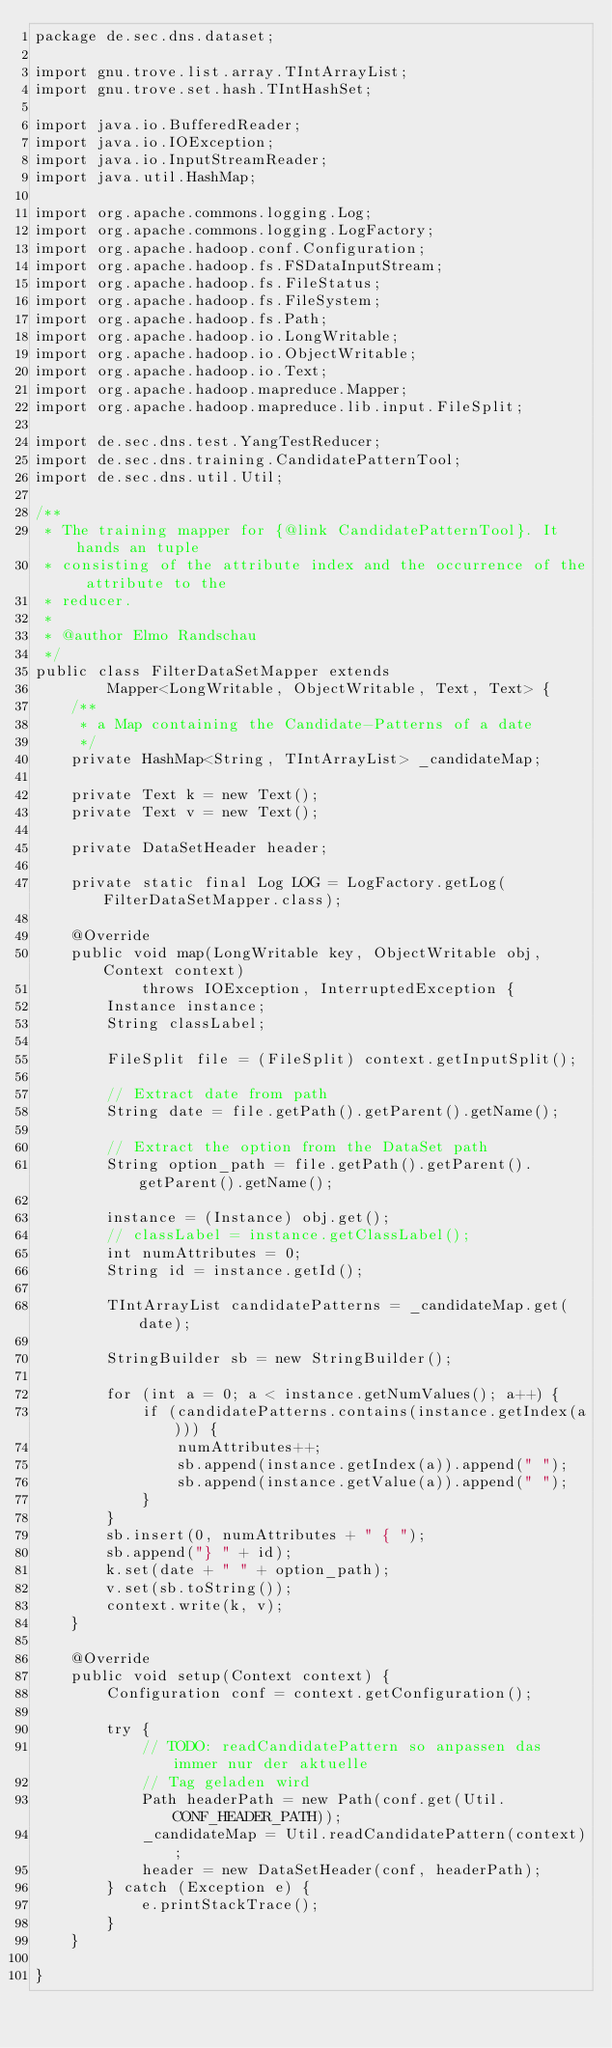<code> <loc_0><loc_0><loc_500><loc_500><_Java_>package de.sec.dns.dataset;

import gnu.trove.list.array.TIntArrayList;
import gnu.trove.set.hash.TIntHashSet;

import java.io.BufferedReader;
import java.io.IOException;
import java.io.InputStreamReader;
import java.util.HashMap;

import org.apache.commons.logging.Log;
import org.apache.commons.logging.LogFactory;
import org.apache.hadoop.conf.Configuration;
import org.apache.hadoop.fs.FSDataInputStream;
import org.apache.hadoop.fs.FileStatus;
import org.apache.hadoop.fs.FileSystem;
import org.apache.hadoop.fs.Path;
import org.apache.hadoop.io.LongWritable;
import org.apache.hadoop.io.ObjectWritable;
import org.apache.hadoop.io.Text;
import org.apache.hadoop.mapreduce.Mapper;
import org.apache.hadoop.mapreduce.lib.input.FileSplit;

import de.sec.dns.test.YangTestReducer;
import de.sec.dns.training.CandidatePatternTool;
import de.sec.dns.util.Util;

/**
 * The training mapper for {@link CandidatePatternTool}. It hands an tuple
 * consisting of the attribute index and the occurrence of the attribute to the
 * reducer.
 * 
 * @author Elmo Randschau
 */
public class FilterDataSetMapper extends
		Mapper<LongWritable, ObjectWritable, Text, Text> {
	/**
	 * a Map containing the Candidate-Patterns of a date
	 */
	private HashMap<String, TIntArrayList> _candidateMap;

	private Text k = new Text();
	private Text v = new Text();

	private DataSetHeader header;

	private static final Log LOG = LogFactory.getLog(FilterDataSetMapper.class);

	@Override
	public void map(LongWritable key, ObjectWritable obj, Context context)
			throws IOException, InterruptedException {
		Instance instance;
		String classLabel;

		FileSplit file = (FileSplit) context.getInputSplit();

		// Extract date from path
		String date = file.getPath().getParent().getName();

		// Extract the option from the DataSet path
		String option_path = file.getPath().getParent().getParent().getName();

		instance = (Instance) obj.get();
		// classLabel = instance.getClassLabel();
		int numAttributes = 0;
		String id = instance.getId();

		TIntArrayList candidatePatterns = _candidateMap.get(date);

		StringBuilder sb = new StringBuilder();

		for (int a = 0; a < instance.getNumValues(); a++) {
			if (candidatePatterns.contains(instance.getIndex(a))) {
				numAttributes++;
				sb.append(instance.getIndex(a)).append(" ");
				sb.append(instance.getValue(a)).append(" ");
			}
		}
		sb.insert(0, numAttributes + " { ");
		sb.append("} " + id);
		k.set(date + " " + option_path);
		v.set(sb.toString());
		context.write(k, v);
	}

	@Override
	public void setup(Context context) {
		Configuration conf = context.getConfiguration();

		try {
			// TODO: readCandidatePattern so anpassen das immer nur der aktuelle
			// Tag geladen wird
			Path headerPath = new Path(conf.get(Util.CONF_HEADER_PATH));
			_candidateMap = Util.readCandidatePattern(context);
			header = new DataSetHeader(conf, headerPath);
		} catch (Exception e) {
			e.printStackTrace();
		}
	}

}
</code> 